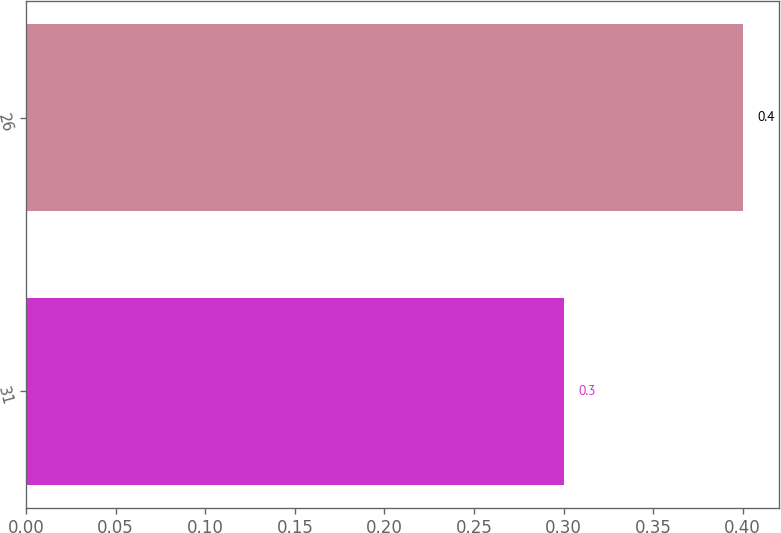<chart> <loc_0><loc_0><loc_500><loc_500><bar_chart><fcel>31<fcel>26<nl><fcel>0.3<fcel>0.4<nl></chart> 